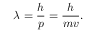<formula> <loc_0><loc_0><loc_500><loc_500>\lambda = { \frac { h } { p } } = { \frac { h } { m v } } .</formula> 